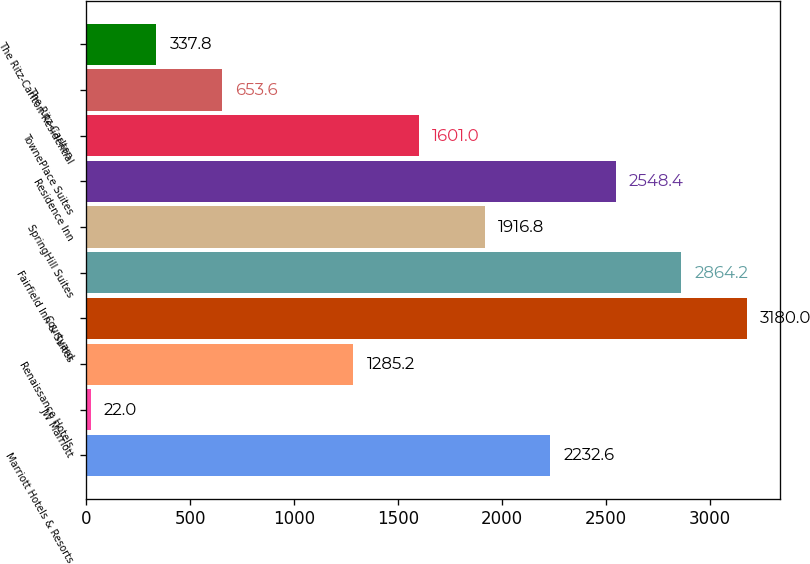<chart> <loc_0><loc_0><loc_500><loc_500><bar_chart><fcel>Marriott Hotels & Resorts<fcel>JW Marriott<fcel>Renaissance Hotels<fcel>Courtyard<fcel>Fairfield Inn & Suites<fcel>SpringHill Suites<fcel>Residence Inn<fcel>TownePlace Suites<fcel>The Ritz-Carlton<fcel>The Ritz-Carlton-Residential<nl><fcel>2232.6<fcel>22<fcel>1285.2<fcel>3180<fcel>2864.2<fcel>1916.8<fcel>2548.4<fcel>1601<fcel>653.6<fcel>337.8<nl></chart> 